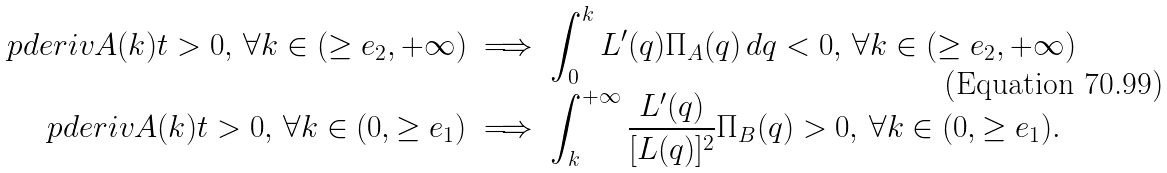Convert formula to latex. <formula><loc_0><loc_0><loc_500><loc_500>\ p d e r i v { A ( k ) } { t } > 0 , \, \forall k \in ( \geq e _ { 2 } , + \infty ) & \implies \int _ { 0 } ^ { k } L ^ { \prime } ( q ) \Pi _ { A } ( q ) \, d q < 0 , \, \forall k \in ( \geq e _ { 2 } , + \infty ) \\ \ p d e r i v { A ( k ) } { t } > 0 , \, \forall k \in ( 0 , \geq e _ { 1 } ) & \implies \int _ { k } ^ { + \infty } \frac { L ^ { \prime } ( q ) } { [ L ( q ) ] ^ { 2 } } \Pi _ { B } ( q ) > 0 , \, \forall k \in ( 0 , \geq e _ { 1 } ) .</formula> 